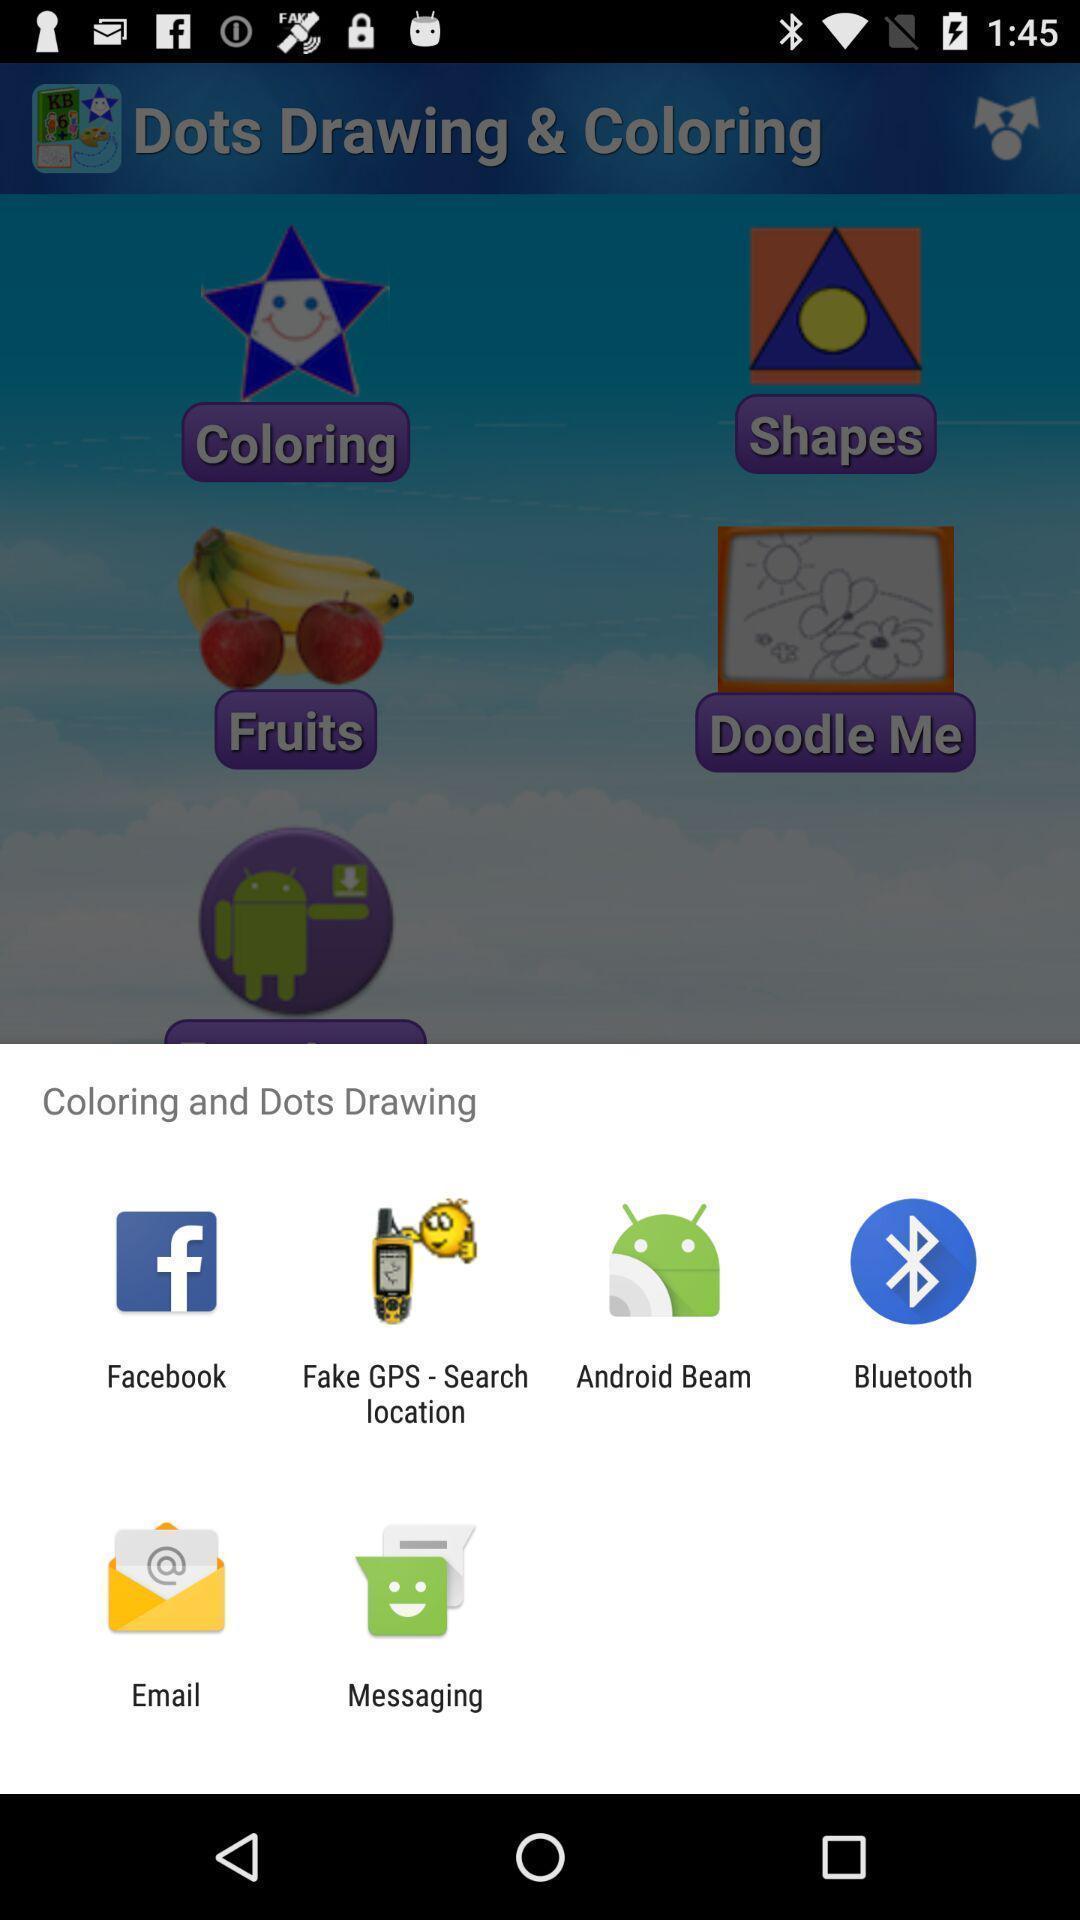Provide a description of this screenshot. Push up message for sharing data via social networks. 